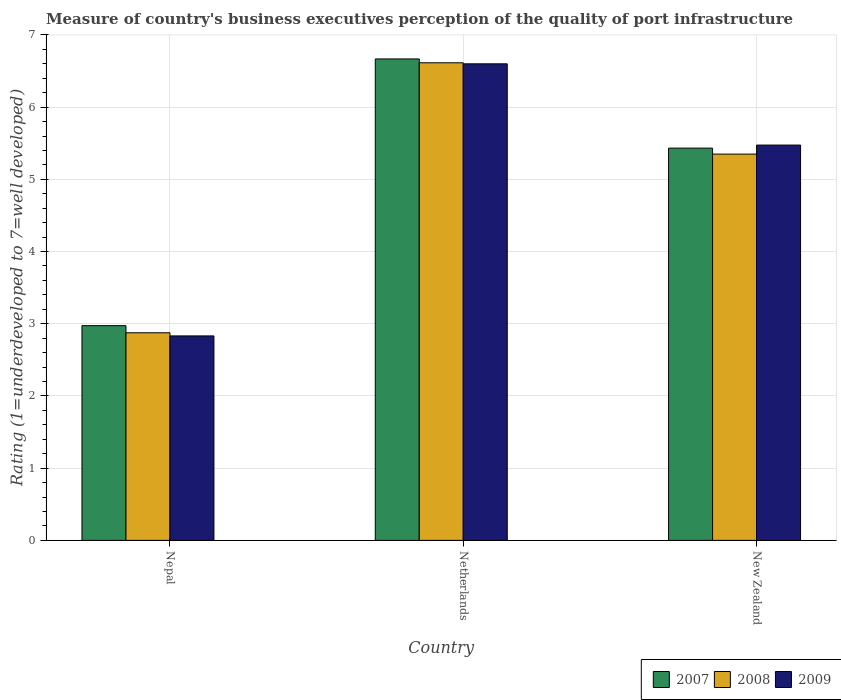Are the number of bars per tick equal to the number of legend labels?
Make the answer very short. Yes. Are the number of bars on each tick of the X-axis equal?
Your response must be concise. Yes. How many bars are there on the 3rd tick from the right?
Keep it short and to the point. 3. What is the label of the 1st group of bars from the left?
Provide a succinct answer. Nepal. In how many cases, is the number of bars for a given country not equal to the number of legend labels?
Your response must be concise. 0. What is the ratings of the quality of port infrastructure in 2008 in New Zealand?
Your answer should be very brief. 5.35. Across all countries, what is the maximum ratings of the quality of port infrastructure in 2008?
Make the answer very short. 6.61. Across all countries, what is the minimum ratings of the quality of port infrastructure in 2009?
Keep it short and to the point. 2.83. In which country was the ratings of the quality of port infrastructure in 2007 minimum?
Give a very brief answer. Nepal. What is the total ratings of the quality of port infrastructure in 2007 in the graph?
Provide a short and direct response. 15.07. What is the difference between the ratings of the quality of port infrastructure in 2008 in Netherlands and that in New Zealand?
Offer a terse response. 1.26. What is the difference between the ratings of the quality of port infrastructure in 2007 in Nepal and the ratings of the quality of port infrastructure in 2008 in Netherlands?
Your answer should be very brief. -3.64. What is the average ratings of the quality of port infrastructure in 2008 per country?
Offer a terse response. 4.95. What is the difference between the ratings of the quality of port infrastructure of/in 2009 and ratings of the quality of port infrastructure of/in 2008 in New Zealand?
Offer a very short reply. 0.13. What is the ratio of the ratings of the quality of port infrastructure in 2007 in Netherlands to that in New Zealand?
Provide a succinct answer. 1.23. Is the ratings of the quality of port infrastructure in 2007 in Netherlands less than that in New Zealand?
Provide a succinct answer. No. Is the difference between the ratings of the quality of port infrastructure in 2009 in Nepal and Netherlands greater than the difference between the ratings of the quality of port infrastructure in 2008 in Nepal and Netherlands?
Your answer should be compact. No. What is the difference between the highest and the second highest ratings of the quality of port infrastructure in 2008?
Make the answer very short. -2.47. What is the difference between the highest and the lowest ratings of the quality of port infrastructure in 2008?
Provide a succinct answer. 3.74. Is the sum of the ratings of the quality of port infrastructure in 2009 in Nepal and Netherlands greater than the maximum ratings of the quality of port infrastructure in 2007 across all countries?
Make the answer very short. Yes. What does the 3rd bar from the left in New Zealand represents?
Your answer should be very brief. 2009. Is it the case that in every country, the sum of the ratings of the quality of port infrastructure in 2009 and ratings of the quality of port infrastructure in 2007 is greater than the ratings of the quality of port infrastructure in 2008?
Offer a terse response. Yes. How many bars are there?
Offer a very short reply. 9. What is the difference between two consecutive major ticks on the Y-axis?
Give a very brief answer. 1. Are the values on the major ticks of Y-axis written in scientific E-notation?
Your answer should be compact. No. Does the graph contain grids?
Provide a succinct answer. Yes. How many legend labels are there?
Provide a short and direct response. 3. How are the legend labels stacked?
Keep it short and to the point. Horizontal. What is the title of the graph?
Provide a short and direct response. Measure of country's business executives perception of the quality of port infrastructure. Does "1968" appear as one of the legend labels in the graph?
Offer a very short reply. No. What is the label or title of the Y-axis?
Your answer should be very brief. Rating (1=underdeveloped to 7=well developed). What is the Rating (1=underdeveloped to 7=well developed) of 2007 in Nepal?
Offer a terse response. 2.97. What is the Rating (1=underdeveloped to 7=well developed) in 2008 in Nepal?
Offer a very short reply. 2.88. What is the Rating (1=underdeveloped to 7=well developed) of 2009 in Nepal?
Keep it short and to the point. 2.83. What is the Rating (1=underdeveloped to 7=well developed) of 2007 in Netherlands?
Offer a terse response. 6.67. What is the Rating (1=underdeveloped to 7=well developed) of 2008 in Netherlands?
Offer a very short reply. 6.61. What is the Rating (1=underdeveloped to 7=well developed) in 2009 in Netherlands?
Make the answer very short. 6.6. What is the Rating (1=underdeveloped to 7=well developed) in 2007 in New Zealand?
Your response must be concise. 5.43. What is the Rating (1=underdeveloped to 7=well developed) in 2008 in New Zealand?
Give a very brief answer. 5.35. What is the Rating (1=underdeveloped to 7=well developed) in 2009 in New Zealand?
Provide a short and direct response. 5.47. Across all countries, what is the maximum Rating (1=underdeveloped to 7=well developed) in 2007?
Provide a short and direct response. 6.67. Across all countries, what is the maximum Rating (1=underdeveloped to 7=well developed) in 2008?
Your answer should be compact. 6.61. Across all countries, what is the maximum Rating (1=underdeveloped to 7=well developed) of 2009?
Provide a short and direct response. 6.6. Across all countries, what is the minimum Rating (1=underdeveloped to 7=well developed) of 2007?
Make the answer very short. 2.97. Across all countries, what is the minimum Rating (1=underdeveloped to 7=well developed) of 2008?
Offer a very short reply. 2.88. Across all countries, what is the minimum Rating (1=underdeveloped to 7=well developed) in 2009?
Offer a very short reply. 2.83. What is the total Rating (1=underdeveloped to 7=well developed) of 2007 in the graph?
Ensure brevity in your answer.  15.07. What is the total Rating (1=underdeveloped to 7=well developed) of 2008 in the graph?
Your answer should be compact. 14.84. What is the total Rating (1=underdeveloped to 7=well developed) of 2009 in the graph?
Offer a very short reply. 14.91. What is the difference between the Rating (1=underdeveloped to 7=well developed) in 2007 in Nepal and that in Netherlands?
Offer a very short reply. -3.69. What is the difference between the Rating (1=underdeveloped to 7=well developed) of 2008 in Nepal and that in Netherlands?
Provide a succinct answer. -3.74. What is the difference between the Rating (1=underdeveloped to 7=well developed) of 2009 in Nepal and that in Netherlands?
Ensure brevity in your answer.  -3.77. What is the difference between the Rating (1=underdeveloped to 7=well developed) of 2007 in Nepal and that in New Zealand?
Keep it short and to the point. -2.46. What is the difference between the Rating (1=underdeveloped to 7=well developed) of 2008 in Nepal and that in New Zealand?
Your answer should be compact. -2.47. What is the difference between the Rating (1=underdeveloped to 7=well developed) in 2009 in Nepal and that in New Zealand?
Ensure brevity in your answer.  -2.64. What is the difference between the Rating (1=underdeveloped to 7=well developed) in 2007 in Netherlands and that in New Zealand?
Your answer should be very brief. 1.23. What is the difference between the Rating (1=underdeveloped to 7=well developed) of 2008 in Netherlands and that in New Zealand?
Your response must be concise. 1.26. What is the difference between the Rating (1=underdeveloped to 7=well developed) of 2009 in Netherlands and that in New Zealand?
Ensure brevity in your answer.  1.13. What is the difference between the Rating (1=underdeveloped to 7=well developed) of 2007 in Nepal and the Rating (1=underdeveloped to 7=well developed) of 2008 in Netherlands?
Offer a very short reply. -3.64. What is the difference between the Rating (1=underdeveloped to 7=well developed) in 2007 in Nepal and the Rating (1=underdeveloped to 7=well developed) in 2009 in Netherlands?
Keep it short and to the point. -3.63. What is the difference between the Rating (1=underdeveloped to 7=well developed) in 2008 in Nepal and the Rating (1=underdeveloped to 7=well developed) in 2009 in Netherlands?
Your answer should be compact. -3.72. What is the difference between the Rating (1=underdeveloped to 7=well developed) in 2007 in Nepal and the Rating (1=underdeveloped to 7=well developed) in 2008 in New Zealand?
Keep it short and to the point. -2.38. What is the difference between the Rating (1=underdeveloped to 7=well developed) in 2007 in Nepal and the Rating (1=underdeveloped to 7=well developed) in 2009 in New Zealand?
Keep it short and to the point. -2.5. What is the difference between the Rating (1=underdeveloped to 7=well developed) in 2008 in Nepal and the Rating (1=underdeveloped to 7=well developed) in 2009 in New Zealand?
Provide a succinct answer. -2.6. What is the difference between the Rating (1=underdeveloped to 7=well developed) in 2007 in Netherlands and the Rating (1=underdeveloped to 7=well developed) in 2008 in New Zealand?
Your response must be concise. 1.32. What is the difference between the Rating (1=underdeveloped to 7=well developed) of 2007 in Netherlands and the Rating (1=underdeveloped to 7=well developed) of 2009 in New Zealand?
Ensure brevity in your answer.  1.19. What is the difference between the Rating (1=underdeveloped to 7=well developed) of 2008 in Netherlands and the Rating (1=underdeveloped to 7=well developed) of 2009 in New Zealand?
Ensure brevity in your answer.  1.14. What is the average Rating (1=underdeveloped to 7=well developed) in 2007 per country?
Give a very brief answer. 5.02. What is the average Rating (1=underdeveloped to 7=well developed) in 2008 per country?
Provide a short and direct response. 4.95. What is the average Rating (1=underdeveloped to 7=well developed) in 2009 per country?
Offer a very short reply. 4.97. What is the difference between the Rating (1=underdeveloped to 7=well developed) in 2007 and Rating (1=underdeveloped to 7=well developed) in 2008 in Nepal?
Ensure brevity in your answer.  0.1. What is the difference between the Rating (1=underdeveloped to 7=well developed) of 2007 and Rating (1=underdeveloped to 7=well developed) of 2009 in Nepal?
Keep it short and to the point. 0.14. What is the difference between the Rating (1=underdeveloped to 7=well developed) of 2008 and Rating (1=underdeveloped to 7=well developed) of 2009 in Nepal?
Your answer should be very brief. 0.04. What is the difference between the Rating (1=underdeveloped to 7=well developed) in 2007 and Rating (1=underdeveloped to 7=well developed) in 2008 in Netherlands?
Make the answer very short. 0.05. What is the difference between the Rating (1=underdeveloped to 7=well developed) of 2007 and Rating (1=underdeveloped to 7=well developed) of 2009 in Netherlands?
Your answer should be compact. 0.07. What is the difference between the Rating (1=underdeveloped to 7=well developed) of 2008 and Rating (1=underdeveloped to 7=well developed) of 2009 in Netherlands?
Offer a very short reply. 0.01. What is the difference between the Rating (1=underdeveloped to 7=well developed) in 2007 and Rating (1=underdeveloped to 7=well developed) in 2008 in New Zealand?
Ensure brevity in your answer.  0.08. What is the difference between the Rating (1=underdeveloped to 7=well developed) in 2007 and Rating (1=underdeveloped to 7=well developed) in 2009 in New Zealand?
Keep it short and to the point. -0.04. What is the difference between the Rating (1=underdeveloped to 7=well developed) in 2008 and Rating (1=underdeveloped to 7=well developed) in 2009 in New Zealand?
Ensure brevity in your answer.  -0.12. What is the ratio of the Rating (1=underdeveloped to 7=well developed) of 2007 in Nepal to that in Netherlands?
Your answer should be very brief. 0.45. What is the ratio of the Rating (1=underdeveloped to 7=well developed) of 2008 in Nepal to that in Netherlands?
Provide a succinct answer. 0.43. What is the ratio of the Rating (1=underdeveloped to 7=well developed) in 2009 in Nepal to that in Netherlands?
Give a very brief answer. 0.43. What is the ratio of the Rating (1=underdeveloped to 7=well developed) in 2007 in Nepal to that in New Zealand?
Provide a short and direct response. 0.55. What is the ratio of the Rating (1=underdeveloped to 7=well developed) of 2008 in Nepal to that in New Zealand?
Provide a short and direct response. 0.54. What is the ratio of the Rating (1=underdeveloped to 7=well developed) of 2009 in Nepal to that in New Zealand?
Your response must be concise. 0.52. What is the ratio of the Rating (1=underdeveloped to 7=well developed) in 2007 in Netherlands to that in New Zealand?
Keep it short and to the point. 1.23. What is the ratio of the Rating (1=underdeveloped to 7=well developed) of 2008 in Netherlands to that in New Zealand?
Your response must be concise. 1.24. What is the ratio of the Rating (1=underdeveloped to 7=well developed) in 2009 in Netherlands to that in New Zealand?
Your answer should be very brief. 1.21. What is the difference between the highest and the second highest Rating (1=underdeveloped to 7=well developed) of 2007?
Make the answer very short. 1.23. What is the difference between the highest and the second highest Rating (1=underdeveloped to 7=well developed) of 2008?
Ensure brevity in your answer.  1.26. What is the difference between the highest and the second highest Rating (1=underdeveloped to 7=well developed) in 2009?
Your answer should be very brief. 1.13. What is the difference between the highest and the lowest Rating (1=underdeveloped to 7=well developed) of 2007?
Make the answer very short. 3.69. What is the difference between the highest and the lowest Rating (1=underdeveloped to 7=well developed) in 2008?
Ensure brevity in your answer.  3.74. What is the difference between the highest and the lowest Rating (1=underdeveloped to 7=well developed) in 2009?
Make the answer very short. 3.77. 